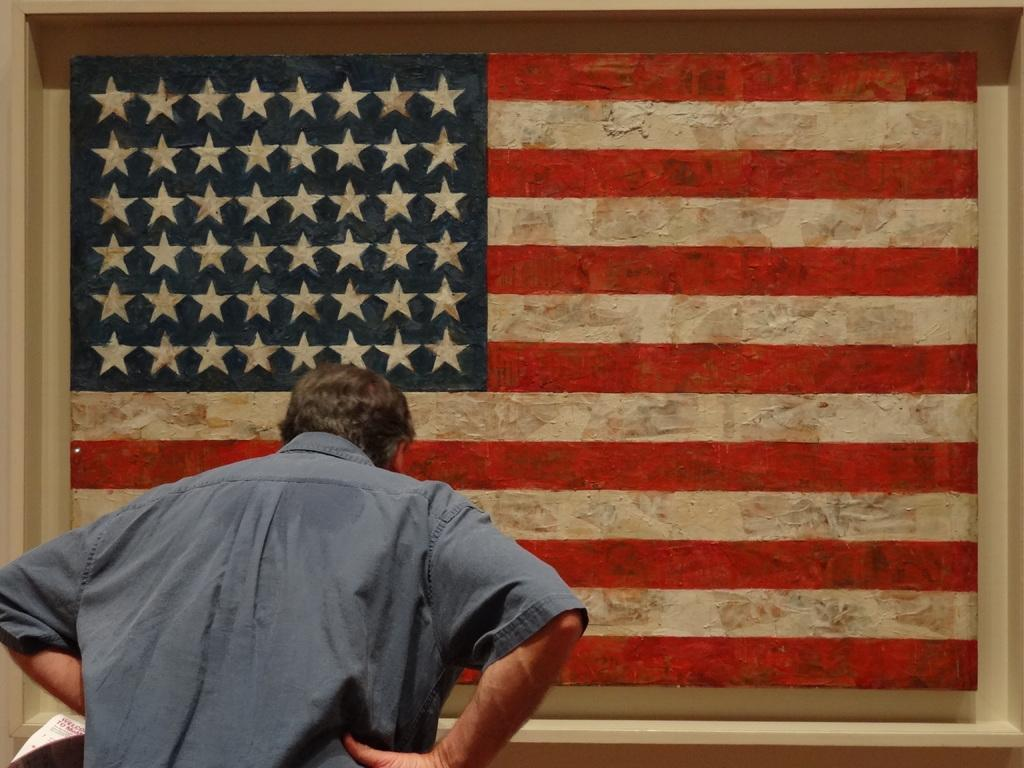Who is the main subject in the image? There is a man in the image. What is the man standing in front of? The man is standing in front of a flag. Where is the flag located? The flag is painted on a wall. What type of fruit is the man holding in the image? There is no fruit present in the image; the man is standing in front of a flag painted on a wall. 